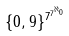Convert formula to latex. <formula><loc_0><loc_0><loc_500><loc_500>\{ 0 , 9 \} ^ { 7 ^ { 7 ^ { \aleph _ { 0 } } } }</formula> 